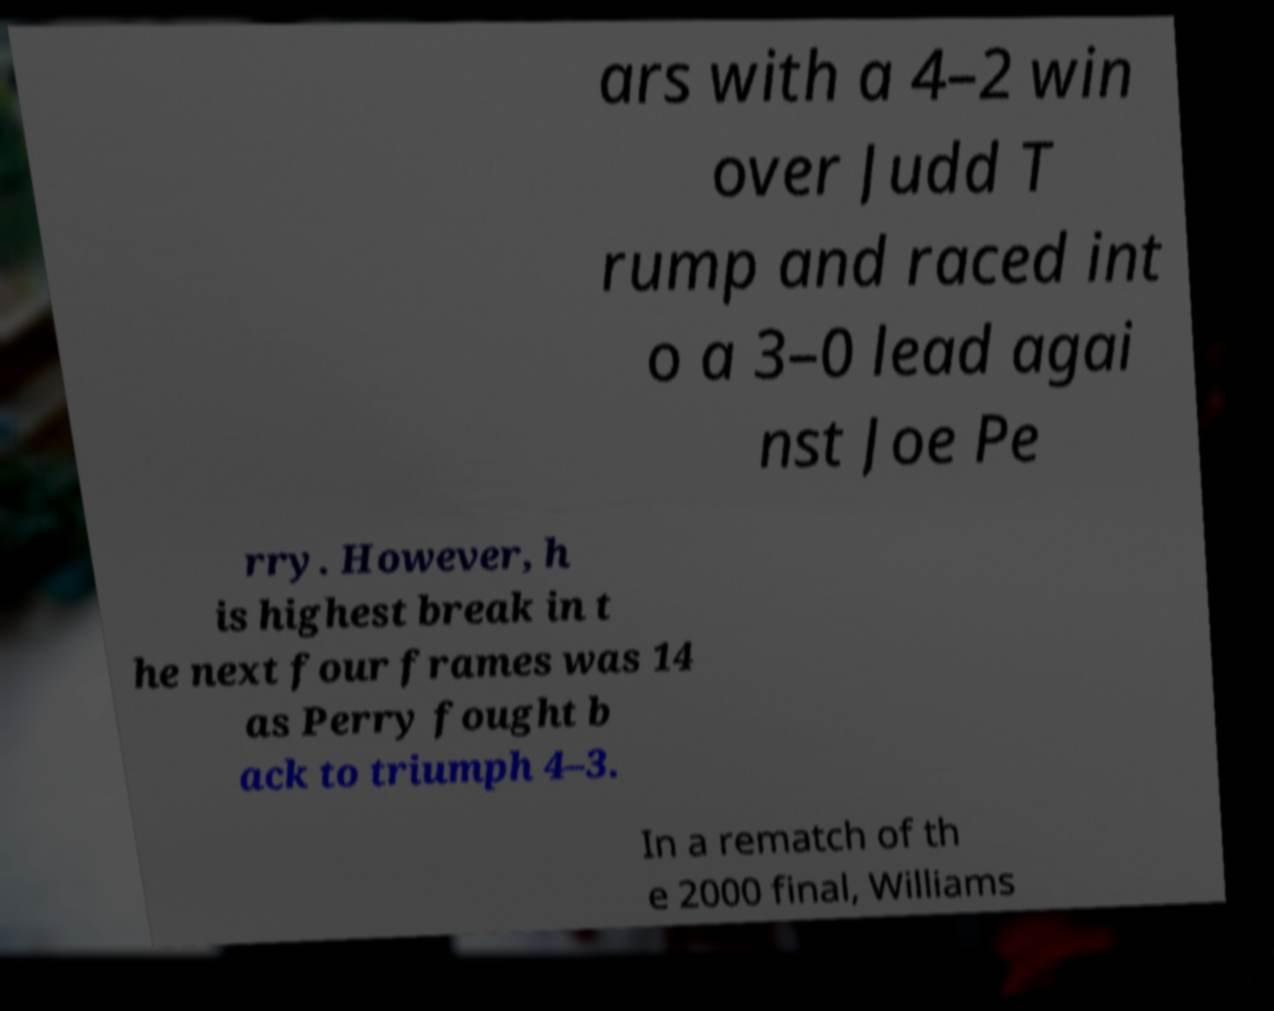There's text embedded in this image that I need extracted. Can you transcribe it verbatim? ars with a 4–2 win over Judd T rump and raced int o a 3–0 lead agai nst Joe Pe rry. However, h is highest break in t he next four frames was 14 as Perry fought b ack to triumph 4–3. In a rematch of th e 2000 final, Williams 